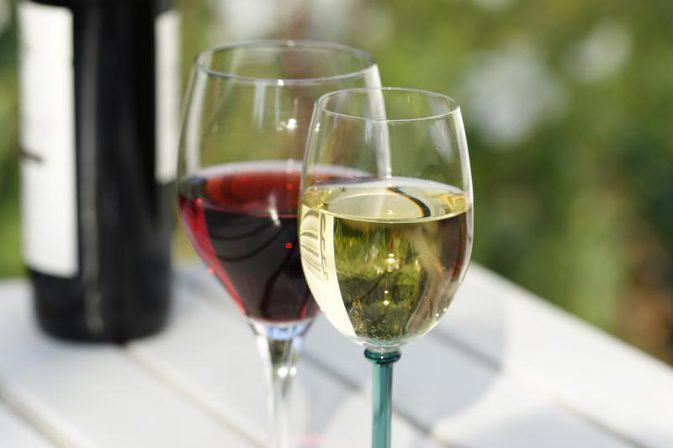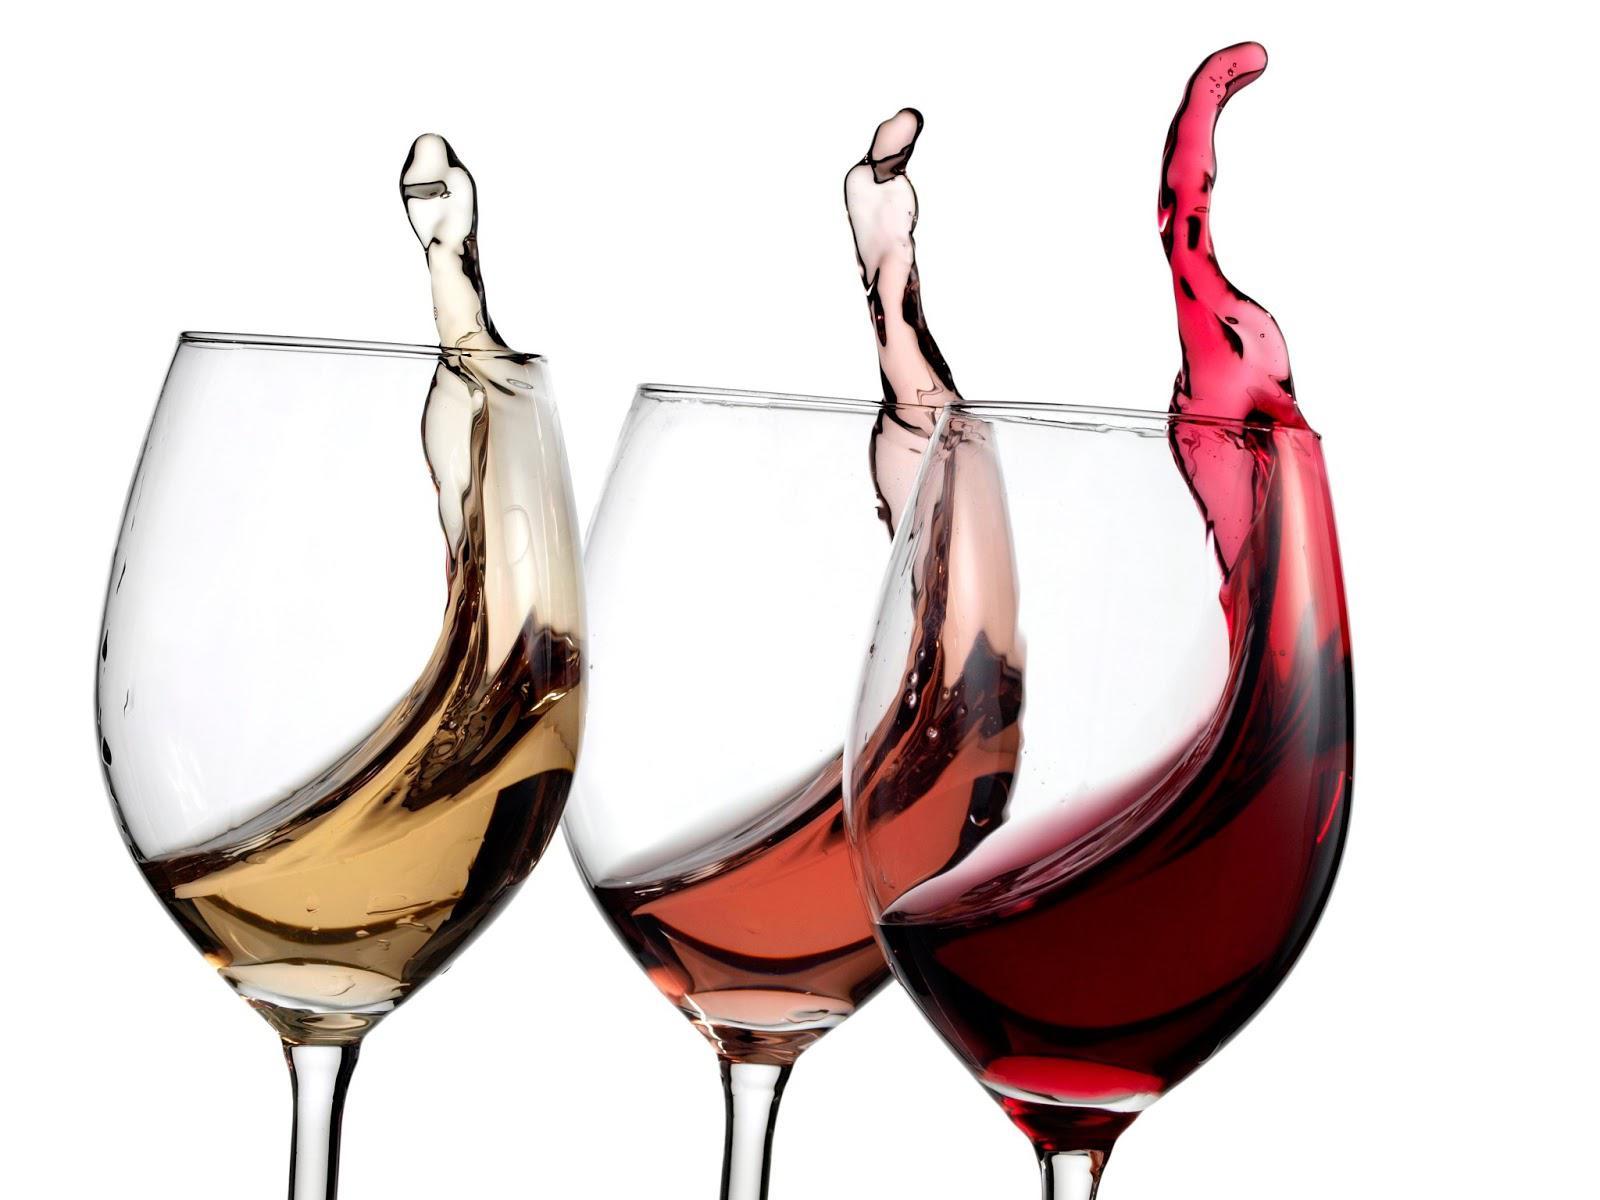The first image is the image on the left, the second image is the image on the right. Given the left and right images, does the statement "In one image, two glasses of wine are sitting before at least one bottle." hold true? Answer yes or no. Yes. 